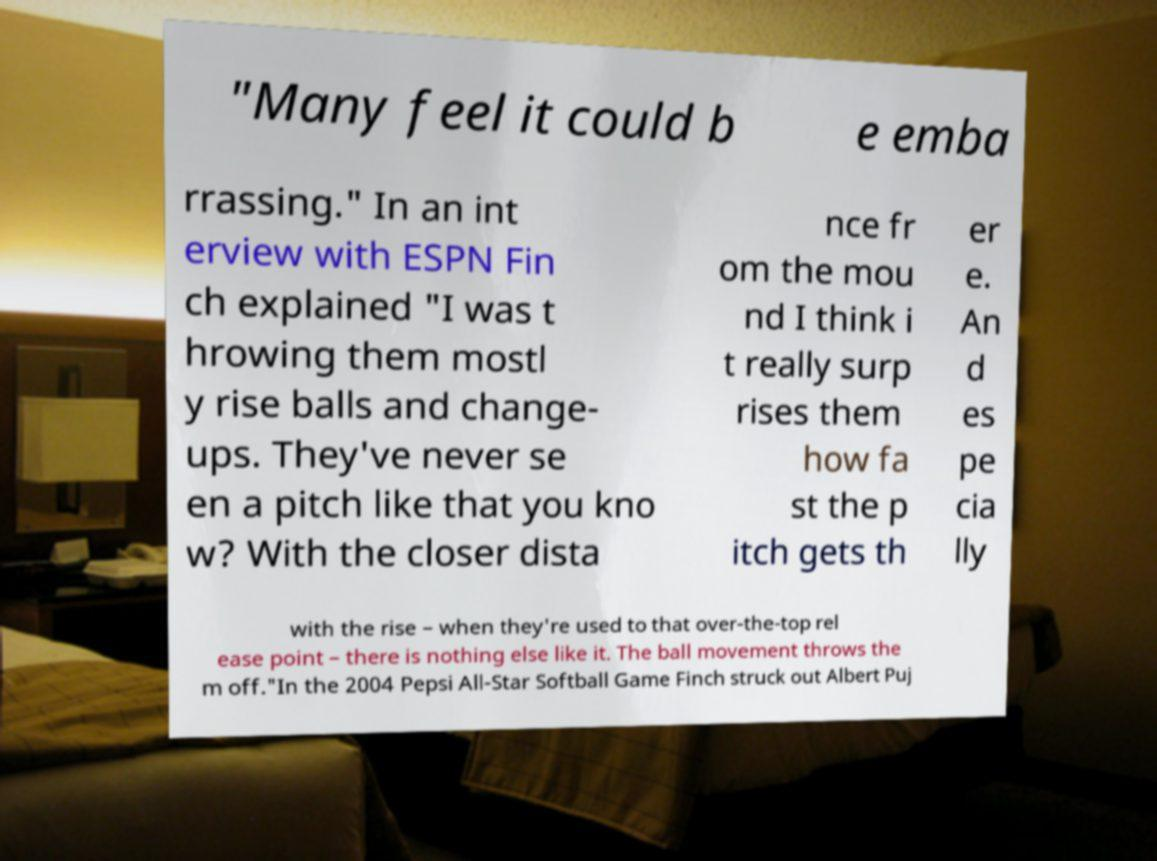Can you read and provide the text displayed in the image?This photo seems to have some interesting text. Can you extract and type it out for me? "Many feel it could b e emba rrassing." In an int erview with ESPN Fin ch explained "I was t hrowing them mostl y rise balls and change- ups. They've never se en a pitch like that you kno w? With the closer dista nce fr om the mou nd I think i t really surp rises them how fa st the p itch gets th er e. An d es pe cia lly with the rise – when they're used to that over-the-top rel ease point – there is nothing else like it. The ball movement throws the m off."In the 2004 Pepsi All-Star Softball Game Finch struck out Albert Puj 